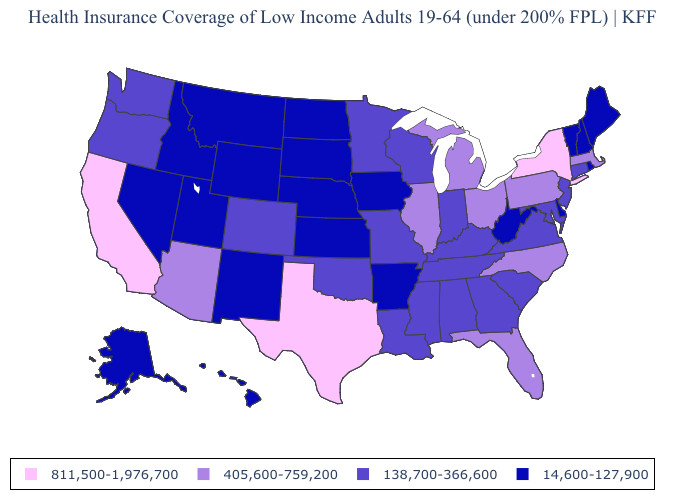Name the states that have a value in the range 405,600-759,200?
Give a very brief answer. Arizona, Florida, Illinois, Massachusetts, Michigan, North Carolina, Ohio, Pennsylvania. What is the value of Colorado?
Write a very short answer. 138,700-366,600. Which states have the lowest value in the MidWest?
Give a very brief answer. Iowa, Kansas, Nebraska, North Dakota, South Dakota. What is the value of Indiana?
Write a very short answer. 138,700-366,600. Does Tennessee have the highest value in the USA?
Keep it brief. No. Name the states that have a value in the range 14,600-127,900?
Answer briefly. Alaska, Arkansas, Delaware, Hawaii, Idaho, Iowa, Kansas, Maine, Montana, Nebraska, Nevada, New Hampshire, New Mexico, North Dakota, Rhode Island, South Dakota, Utah, Vermont, West Virginia, Wyoming. How many symbols are there in the legend?
Answer briefly. 4. Name the states that have a value in the range 138,700-366,600?
Quick response, please. Alabama, Colorado, Connecticut, Georgia, Indiana, Kentucky, Louisiana, Maryland, Minnesota, Mississippi, Missouri, New Jersey, Oklahoma, Oregon, South Carolina, Tennessee, Virginia, Washington, Wisconsin. What is the value of Oklahoma?
Be succinct. 138,700-366,600. Does Minnesota have a lower value than Texas?
Quick response, please. Yes. What is the lowest value in the MidWest?
Concise answer only. 14,600-127,900. Does the first symbol in the legend represent the smallest category?
Give a very brief answer. No. Does Colorado have the highest value in the USA?
Quick response, please. No. What is the value of Indiana?
Give a very brief answer. 138,700-366,600. Name the states that have a value in the range 14,600-127,900?
Write a very short answer. Alaska, Arkansas, Delaware, Hawaii, Idaho, Iowa, Kansas, Maine, Montana, Nebraska, Nevada, New Hampshire, New Mexico, North Dakota, Rhode Island, South Dakota, Utah, Vermont, West Virginia, Wyoming. 